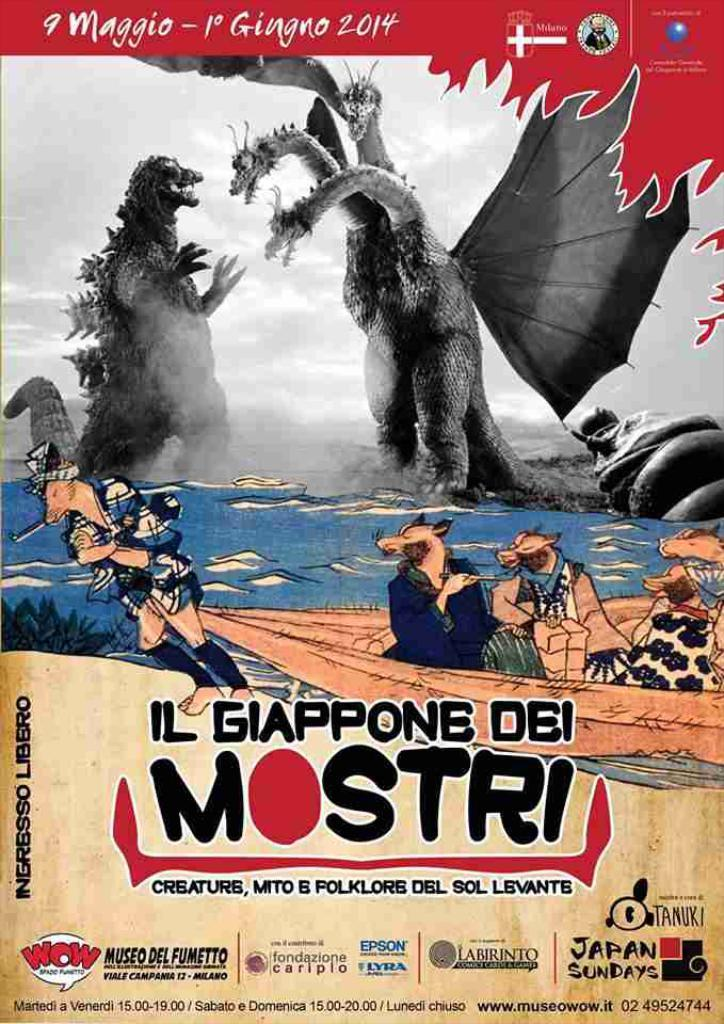<image>
Relay a brief, clear account of the picture shown. A poster for a monster movie IL GIAPPONE DEI MOSTRI. 